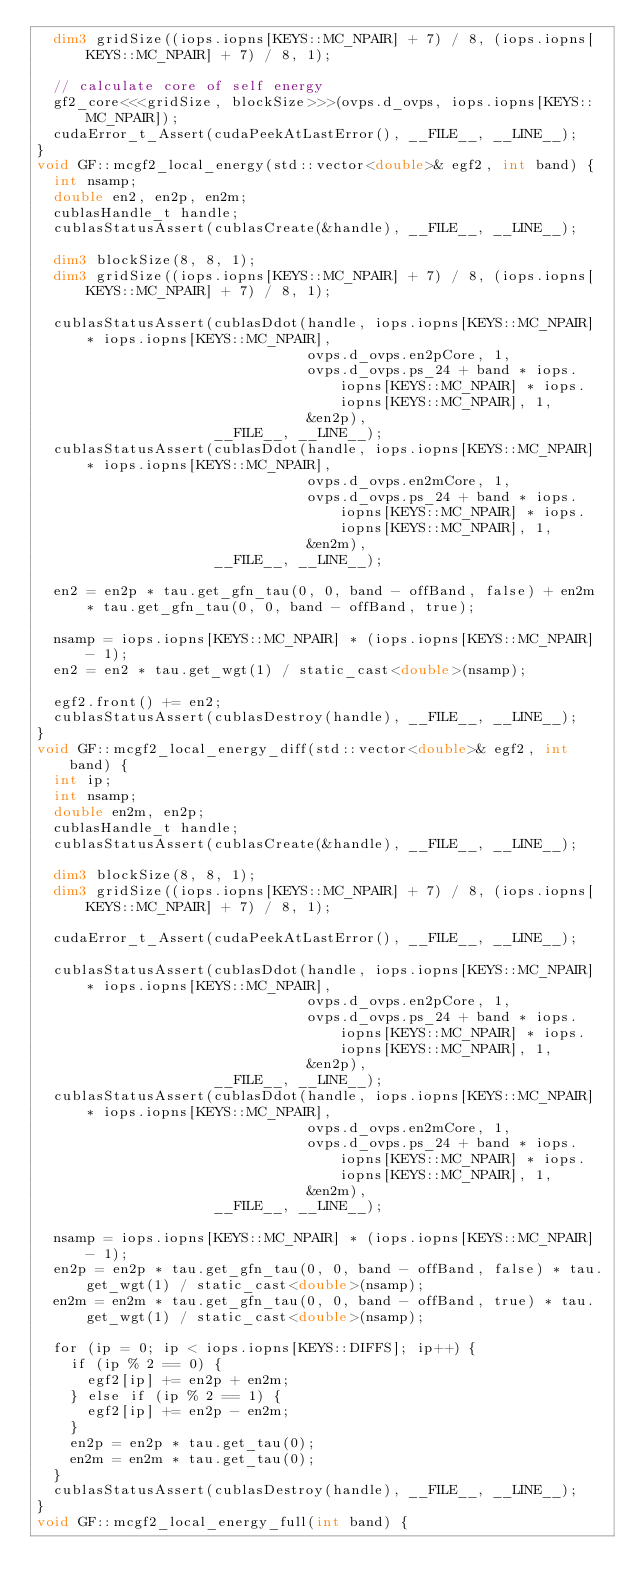<code> <loc_0><loc_0><loc_500><loc_500><_Cuda_>  dim3 gridSize((iops.iopns[KEYS::MC_NPAIR] + 7) / 8, (iops.iopns[KEYS::MC_NPAIR] + 7) / 8, 1);

  // calculate core of self energy
  gf2_core<<<gridSize, blockSize>>>(ovps.d_ovps, iops.iopns[KEYS::MC_NPAIR]);
  cudaError_t_Assert(cudaPeekAtLastError(), __FILE__, __LINE__);
}
void GF::mcgf2_local_energy(std::vector<double>& egf2, int band) {
  int nsamp;
  double en2, en2p, en2m;
  cublasHandle_t handle;
  cublasStatusAssert(cublasCreate(&handle), __FILE__, __LINE__);

  dim3 blockSize(8, 8, 1);
  dim3 gridSize((iops.iopns[KEYS::MC_NPAIR] + 7) / 8, (iops.iopns[KEYS::MC_NPAIR] + 7) / 8, 1);

  cublasStatusAssert(cublasDdot(handle, iops.iopns[KEYS::MC_NPAIR] * iops.iopns[KEYS::MC_NPAIR],
                                ovps.d_ovps.en2pCore, 1,
                                ovps.d_ovps.ps_24 + band * iops.iopns[KEYS::MC_NPAIR] * iops.iopns[KEYS::MC_NPAIR], 1,
                                &en2p),
                     __FILE__, __LINE__);
  cublasStatusAssert(cublasDdot(handle, iops.iopns[KEYS::MC_NPAIR] * iops.iopns[KEYS::MC_NPAIR],
                                ovps.d_ovps.en2mCore, 1,
                                ovps.d_ovps.ps_24 + band * iops.iopns[KEYS::MC_NPAIR] * iops.iopns[KEYS::MC_NPAIR], 1,
                                &en2m),
                     __FILE__, __LINE__);

  en2 = en2p * tau.get_gfn_tau(0, 0, band - offBand, false) + en2m * tau.get_gfn_tau(0, 0, band - offBand, true);

  nsamp = iops.iopns[KEYS::MC_NPAIR] * (iops.iopns[KEYS::MC_NPAIR] - 1);
  en2 = en2 * tau.get_wgt(1) / static_cast<double>(nsamp);

  egf2.front() += en2;
  cublasStatusAssert(cublasDestroy(handle), __FILE__, __LINE__);
}
void GF::mcgf2_local_energy_diff(std::vector<double>& egf2, int band) {
  int ip;
  int nsamp;
  double en2m, en2p;
  cublasHandle_t handle;
  cublasStatusAssert(cublasCreate(&handle), __FILE__, __LINE__);

  dim3 blockSize(8, 8, 1);
  dim3 gridSize((iops.iopns[KEYS::MC_NPAIR] + 7) / 8, (iops.iopns[KEYS::MC_NPAIR] + 7) / 8, 1);

  cudaError_t_Assert(cudaPeekAtLastError(), __FILE__, __LINE__);

  cublasStatusAssert(cublasDdot(handle, iops.iopns[KEYS::MC_NPAIR] * iops.iopns[KEYS::MC_NPAIR],
                                ovps.d_ovps.en2pCore, 1,
                                ovps.d_ovps.ps_24 + band * iops.iopns[KEYS::MC_NPAIR] * iops.iopns[KEYS::MC_NPAIR], 1,
                                &en2p),
                     __FILE__, __LINE__);
  cublasStatusAssert(cublasDdot(handle, iops.iopns[KEYS::MC_NPAIR] * iops.iopns[KEYS::MC_NPAIR],
                                ovps.d_ovps.en2mCore, 1,
                                ovps.d_ovps.ps_24 + band * iops.iopns[KEYS::MC_NPAIR] * iops.iopns[KEYS::MC_NPAIR], 1,
                                &en2m),
                     __FILE__, __LINE__);

  nsamp = iops.iopns[KEYS::MC_NPAIR] * (iops.iopns[KEYS::MC_NPAIR] - 1);
  en2p = en2p * tau.get_gfn_tau(0, 0, band - offBand, false) * tau.get_wgt(1) / static_cast<double>(nsamp);
  en2m = en2m * tau.get_gfn_tau(0, 0, band - offBand, true) * tau.get_wgt(1) / static_cast<double>(nsamp);

  for (ip = 0; ip < iops.iopns[KEYS::DIFFS]; ip++) {
    if (ip % 2 == 0) {
      egf2[ip] += en2p + en2m;
    } else if (ip % 2 == 1) {
      egf2[ip] += en2p - en2m;
    }
    en2p = en2p * tau.get_tau(0);
    en2m = en2m * tau.get_tau(0);
  }
  cublasStatusAssert(cublasDestroy(handle), __FILE__, __LINE__);
}
void GF::mcgf2_local_energy_full(int band) {</code> 